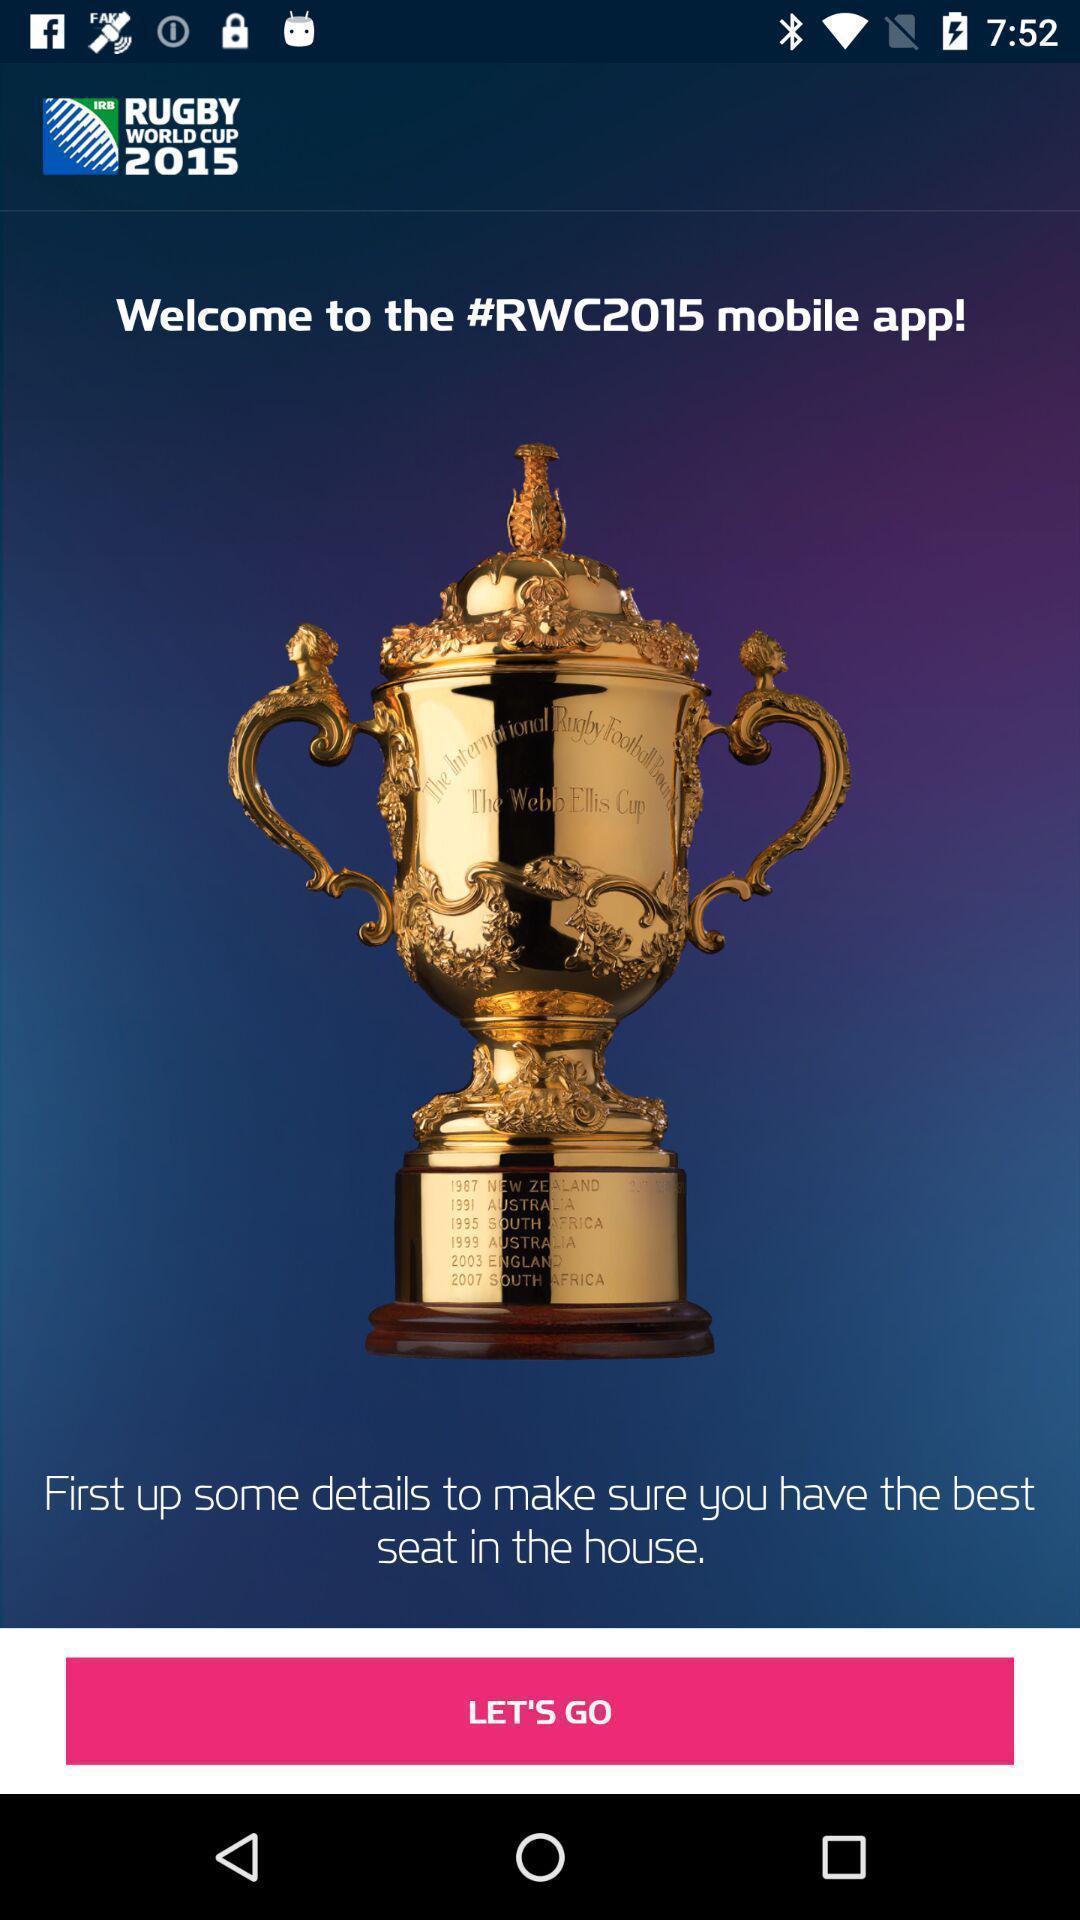Describe the key features of this screenshot. Welcome page with lets go button in sports app. 